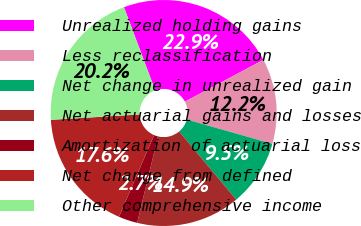Convert chart to OTSL. <chart><loc_0><loc_0><loc_500><loc_500><pie_chart><fcel>Unrealized holding gains<fcel>Less reclassification<fcel>Net change in unrealized gain<fcel>Net actuarial gains and losses<fcel>Amortization of actuarial loss<fcel>Net change from defined<fcel>Other comprehensive income<nl><fcel>22.93%<fcel>12.19%<fcel>9.5%<fcel>14.87%<fcel>2.71%<fcel>17.56%<fcel>20.25%<nl></chart> 